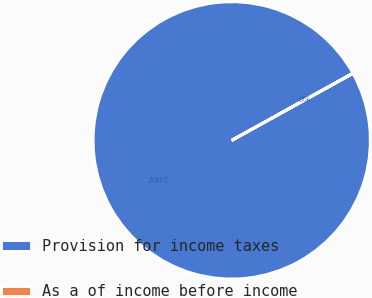Convert chart to OTSL. <chart><loc_0><loc_0><loc_500><loc_500><pie_chart><fcel>Provision for income taxes<fcel>As a of income before income<nl><fcel>99.99%<fcel>0.01%<nl></chart> 